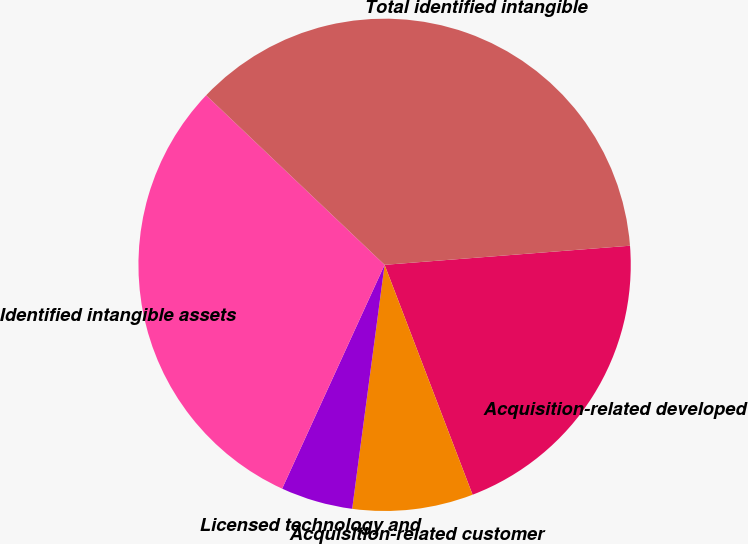Convert chart to OTSL. <chart><loc_0><loc_0><loc_500><loc_500><pie_chart><fcel>Acquisition-related developed<fcel>Acquisition-related customer<fcel>Licensed technology and<fcel>Identified intangible assets<fcel>Total identified intangible<nl><fcel>20.42%<fcel>7.92%<fcel>4.73%<fcel>30.26%<fcel>36.67%<nl></chart> 